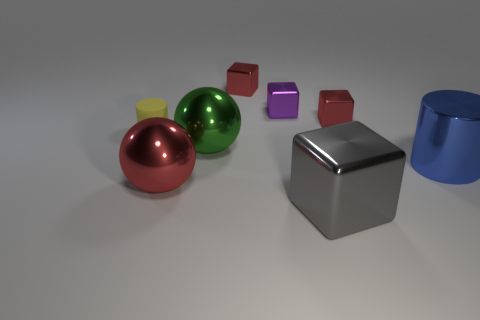How many spheres are either large objects or big green objects?
Make the answer very short. 2. The big cylinder that is made of the same material as the large gray cube is what color?
Make the answer very short. Blue. Does the rubber cylinder in front of the purple shiny block have the same size as the tiny purple metal block?
Your answer should be compact. Yes. Do the gray thing and the cylinder to the left of the big gray metallic cube have the same material?
Your answer should be very brief. No. There is a small metal thing that is in front of the purple metal thing; what color is it?
Offer a very short reply. Red. Is there a red metallic object that is to the right of the large shiny thing that is on the left side of the large green object?
Your answer should be very brief. Yes. Is the color of the big metal thing that is behind the blue shiny object the same as the metal block that is right of the gray object?
Ensure brevity in your answer.  No. There is a yellow rubber thing; how many cylinders are on the left side of it?
Offer a terse response. 0. Does the red thing in front of the big green metallic thing have the same material as the yellow object?
Offer a terse response. No. How many big blue cylinders are made of the same material as the big red ball?
Make the answer very short. 1. 